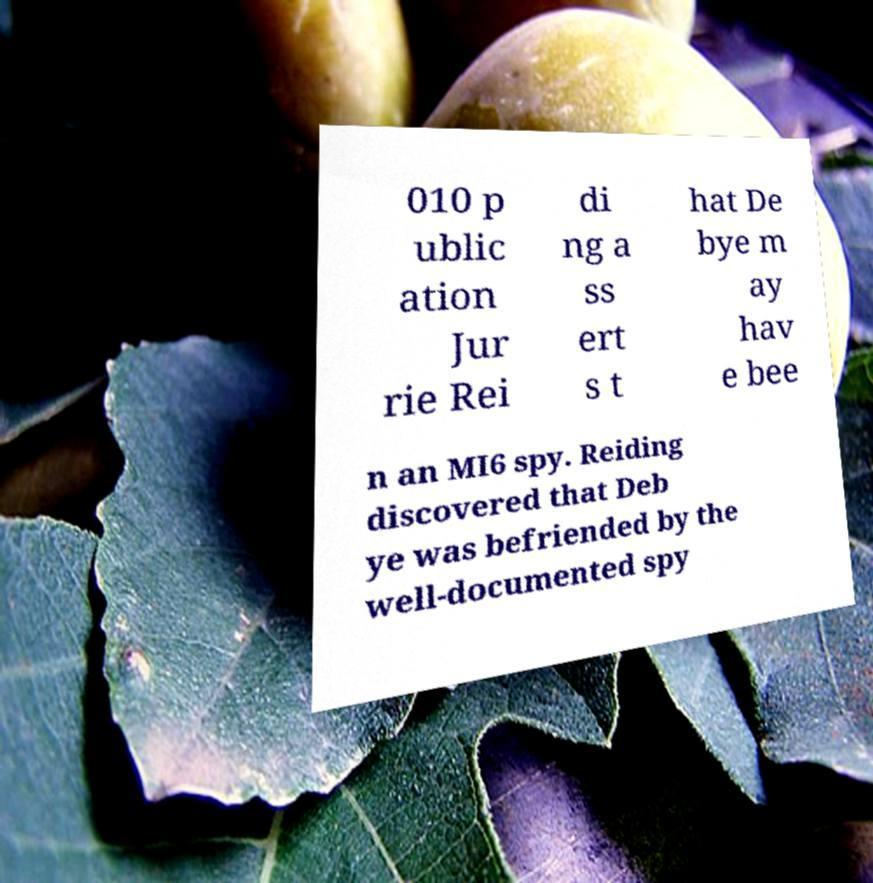Please read and relay the text visible in this image. What does it say? 010 p ublic ation Jur rie Rei di ng a ss ert s t hat De bye m ay hav e bee n an MI6 spy. Reiding discovered that Deb ye was befriended by the well-documented spy 